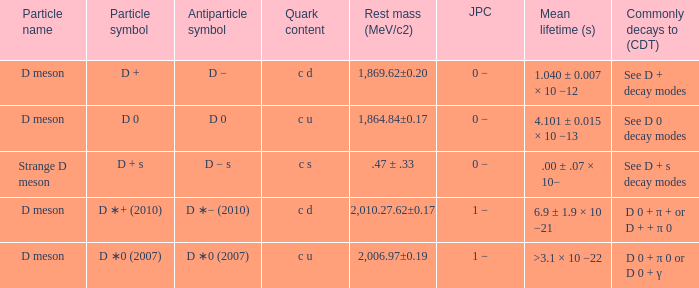What is the antiparticle symbol with a rest mess (mev/c2) of .47 ± .33? D − s. 